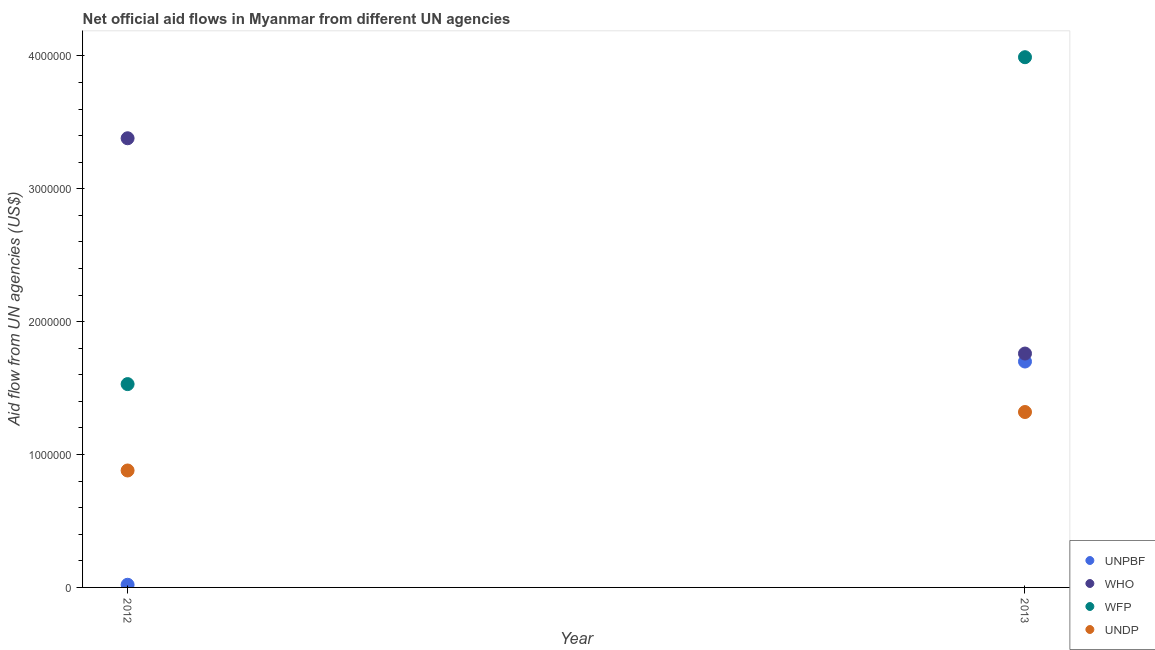How many different coloured dotlines are there?
Keep it short and to the point. 4. Is the number of dotlines equal to the number of legend labels?
Your response must be concise. Yes. What is the amount of aid given by who in 2013?
Keep it short and to the point. 1.76e+06. Across all years, what is the maximum amount of aid given by unpbf?
Offer a terse response. 1.70e+06. Across all years, what is the minimum amount of aid given by undp?
Keep it short and to the point. 8.80e+05. What is the total amount of aid given by unpbf in the graph?
Your response must be concise. 1.72e+06. What is the difference between the amount of aid given by wfp in 2012 and that in 2013?
Provide a short and direct response. -2.46e+06. What is the difference between the amount of aid given by unpbf in 2012 and the amount of aid given by undp in 2013?
Provide a succinct answer. -1.30e+06. What is the average amount of aid given by wfp per year?
Offer a terse response. 2.76e+06. In the year 2013, what is the difference between the amount of aid given by undp and amount of aid given by wfp?
Offer a very short reply. -2.67e+06. What is the ratio of the amount of aid given by unpbf in 2012 to that in 2013?
Your response must be concise. 0.01. In how many years, is the amount of aid given by undp greater than the average amount of aid given by undp taken over all years?
Provide a short and direct response. 1. Is it the case that in every year, the sum of the amount of aid given by unpbf and amount of aid given by who is greater than the sum of amount of aid given by undp and amount of aid given by wfp?
Your answer should be very brief. No. Is it the case that in every year, the sum of the amount of aid given by unpbf and amount of aid given by who is greater than the amount of aid given by wfp?
Offer a terse response. No. Does the amount of aid given by unpbf monotonically increase over the years?
Your response must be concise. Yes. How many dotlines are there?
Provide a short and direct response. 4. How many years are there in the graph?
Provide a succinct answer. 2. Does the graph contain any zero values?
Your response must be concise. No. Where does the legend appear in the graph?
Provide a short and direct response. Bottom right. How many legend labels are there?
Offer a very short reply. 4. How are the legend labels stacked?
Provide a succinct answer. Vertical. What is the title of the graph?
Your answer should be very brief. Net official aid flows in Myanmar from different UN agencies. Does "Interest Payments" appear as one of the legend labels in the graph?
Your answer should be compact. No. What is the label or title of the X-axis?
Offer a terse response. Year. What is the label or title of the Y-axis?
Provide a succinct answer. Aid flow from UN agencies (US$). What is the Aid flow from UN agencies (US$) in UNPBF in 2012?
Your response must be concise. 2.00e+04. What is the Aid flow from UN agencies (US$) of WHO in 2012?
Ensure brevity in your answer.  3.38e+06. What is the Aid flow from UN agencies (US$) in WFP in 2012?
Provide a short and direct response. 1.53e+06. What is the Aid flow from UN agencies (US$) in UNDP in 2012?
Make the answer very short. 8.80e+05. What is the Aid flow from UN agencies (US$) of UNPBF in 2013?
Your answer should be compact. 1.70e+06. What is the Aid flow from UN agencies (US$) in WHO in 2013?
Make the answer very short. 1.76e+06. What is the Aid flow from UN agencies (US$) in WFP in 2013?
Your answer should be very brief. 3.99e+06. What is the Aid flow from UN agencies (US$) of UNDP in 2013?
Ensure brevity in your answer.  1.32e+06. Across all years, what is the maximum Aid flow from UN agencies (US$) of UNPBF?
Offer a terse response. 1.70e+06. Across all years, what is the maximum Aid flow from UN agencies (US$) in WHO?
Keep it short and to the point. 3.38e+06. Across all years, what is the maximum Aid flow from UN agencies (US$) of WFP?
Give a very brief answer. 3.99e+06. Across all years, what is the maximum Aid flow from UN agencies (US$) of UNDP?
Your answer should be very brief. 1.32e+06. Across all years, what is the minimum Aid flow from UN agencies (US$) of UNPBF?
Your answer should be very brief. 2.00e+04. Across all years, what is the minimum Aid flow from UN agencies (US$) of WHO?
Your response must be concise. 1.76e+06. Across all years, what is the minimum Aid flow from UN agencies (US$) of WFP?
Provide a succinct answer. 1.53e+06. Across all years, what is the minimum Aid flow from UN agencies (US$) in UNDP?
Give a very brief answer. 8.80e+05. What is the total Aid flow from UN agencies (US$) in UNPBF in the graph?
Make the answer very short. 1.72e+06. What is the total Aid flow from UN agencies (US$) in WHO in the graph?
Provide a short and direct response. 5.14e+06. What is the total Aid flow from UN agencies (US$) in WFP in the graph?
Your response must be concise. 5.52e+06. What is the total Aid flow from UN agencies (US$) in UNDP in the graph?
Give a very brief answer. 2.20e+06. What is the difference between the Aid flow from UN agencies (US$) in UNPBF in 2012 and that in 2013?
Ensure brevity in your answer.  -1.68e+06. What is the difference between the Aid flow from UN agencies (US$) of WHO in 2012 and that in 2013?
Ensure brevity in your answer.  1.62e+06. What is the difference between the Aid flow from UN agencies (US$) in WFP in 2012 and that in 2013?
Your answer should be very brief. -2.46e+06. What is the difference between the Aid flow from UN agencies (US$) in UNDP in 2012 and that in 2013?
Keep it short and to the point. -4.40e+05. What is the difference between the Aid flow from UN agencies (US$) in UNPBF in 2012 and the Aid flow from UN agencies (US$) in WHO in 2013?
Your response must be concise. -1.74e+06. What is the difference between the Aid flow from UN agencies (US$) in UNPBF in 2012 and the Aid flow from UN agencies (US$) in WFP in 2013?
Your answer should be very brief. -3.97e+06. What is the difference between the Aid flow from UN agencies (US$) in UNPBF in 2012 and the Aid flow from UN agencies (US$) in UNDP in 2013?
Make the answer very short. -1.30e+06. What is the difference between the Aid flow from UN agencies (US$) of WHO in 2012 and the Aid flow from UN agencies (US$) of WFP in 2013?
Your answer should be compact. -6.10e+05. What is the difference between the Aid flow from UN agencies (US$) of WHO in 2012 and the Aid flow from UN agencies (US$) of UNDP in 2013?
Ensure brevity in your answer.  2.06e+06. What is the difference between the Aid flow from UN agencies (US$) of WFP in 2012 and the Aid flow from UN agencies (US$) of UNDP in 2013?
Provide a short and direct response. 2.10e+05. What is the average Aid flow from UN agencies (US$) of UNPBF per year?
Offer a terse response. 8.60e+05. What is the average Aid flow from UN agencies (US$) in WHO per year?
Your response must be concise. 2.57e+06. What is the average Aid flow from UN agencies (US$) in WFP per year?
Your answer should be compact. 2.76e+06. What is the average Aid flow from UN agencies (US$) of UNDP per year?
Offer a very short reply. 1.10e+06. In the year 2012, what is the difference between the Aid flow from UN agencies (US$) of UNPBF and Aid flow from UN agencies (US$) of WHO?
Keep it short and to the point. -3.36e+06. In the year 2012, what is the difference between the Aid flow from UN agencies (US$) in UNPBF and Aid flow from UN agencies (US$) in WFP?
Offer a terse response. -1.51e+06. In the year 2012, what is the difference between the Aid flow from UN agencies (US$) of UNPBF and Aid flow from UN agencies (US$) of UNDP?
Your answer should be very brief. -8.60e+05. In the year 2012, what is the difference between the Aid flow from UN agencies (US$) in WHO and Aid flow from UN agencies (US$) in WFP?
Your response must be concise. 1.85e+06. In the year 2012, what is the difference between the Aid flow from UN agencies (US$) of WHO and Aid flow from UN agencies (US$) of UNDP?
Give a very brief answer. 2.50e+06. In the year 2012, what is the difference between the Aid flow from UN agencies (US$) in WFP and Aid flow from UN agencies (US$) in UNDP?
Make the answer very short. 6.50e+05. In the year 2013, what is the difference between the Aid flow from UN agencies (US$) of UNPBF and Aid flow from UN agencies (US$) of WHO?
Your answer should be very brief. -6.00e+04. In the year 2013, what is the difference between the Aid flow from UN agencies (US$) in UNPBF and Aid flow from UN agencies (US$) in WFP?
Offer a very short reply. -2.29e+06. In the year 2013, what is the difference between the Aid flow from UN agencies (US$) of UNPBF and Aid flow from UN agencies (US$) of UNDP?
Your answer should be very brief. 3.80e+05. In the year 2013, what is the difference between the Aid flow from UN agencies (US$) in WHO and Aid flow from UN agencies (US$) in WFP?
Keep it short and to the point. -2.23e+06. In the year 2013, what is the difference between the Aid flow from UN agencies (US$) in WFP and Aid flow from UN agencies (US$) in UNDP?
Your answer should be compact. 2.67e+06. What is the ratio of the Aid flow from UN agencies (US$) of UNPBF in 2012 to that in 2013?
Offer a very short reply. 0.01. What is the ratio of the Aid flow from UN agencies (US$) of WHO in 2012 to that in 2013?
Ensure brevity in your answer.  1.92. What is the ratio of the Aid flow from UN agencies (US$) of WFP in 2012 to that in 2013?
Your response must be concise. 0.38. What is the ratio of the Aid flow from UN agencies (US$) in UNDP in 2012 to that in 2013?
Keep it short and to the point. 0.67. What is the difference between the highest and the second highest Aid flow from UN agencies (US$) in UNPBF?
Provide a succinct answer. 1.68e+06. What is the difference between the highest and the second highest Aid flow from UN agencies (US$) in WHO?
Give a very brief answer. 1.62e+06. What is the difference between the highest and the second highest Aid flow from UN agencies (US$) of WFP?
Your response must be concise. 2.46e+06. What is the difference between the highest and the second highest Aid flow from UN agencies (US$) of UNDP?
Make the answer very short. 4.40e+05. What is the difference between the highest and the lowest Aid flow from UN agencies (US$) of UNPBF?
Keep it short and to the point. 1.68e+06. What is the difference between the highest and the lowest Aid flow from UN agencies (US$) of WHO?
Provide a short and direct response. 1.62e+06. What is the difference between the highest and the lowest Aid flow from UN agencies (US$) in WFP?
Make the answer very short. 2.46e+06. What is the difference between the highest and the lowest Aid flow from UN agencies (US$) in UNDP?
Your answer should be very brief. 4.40e+05. 